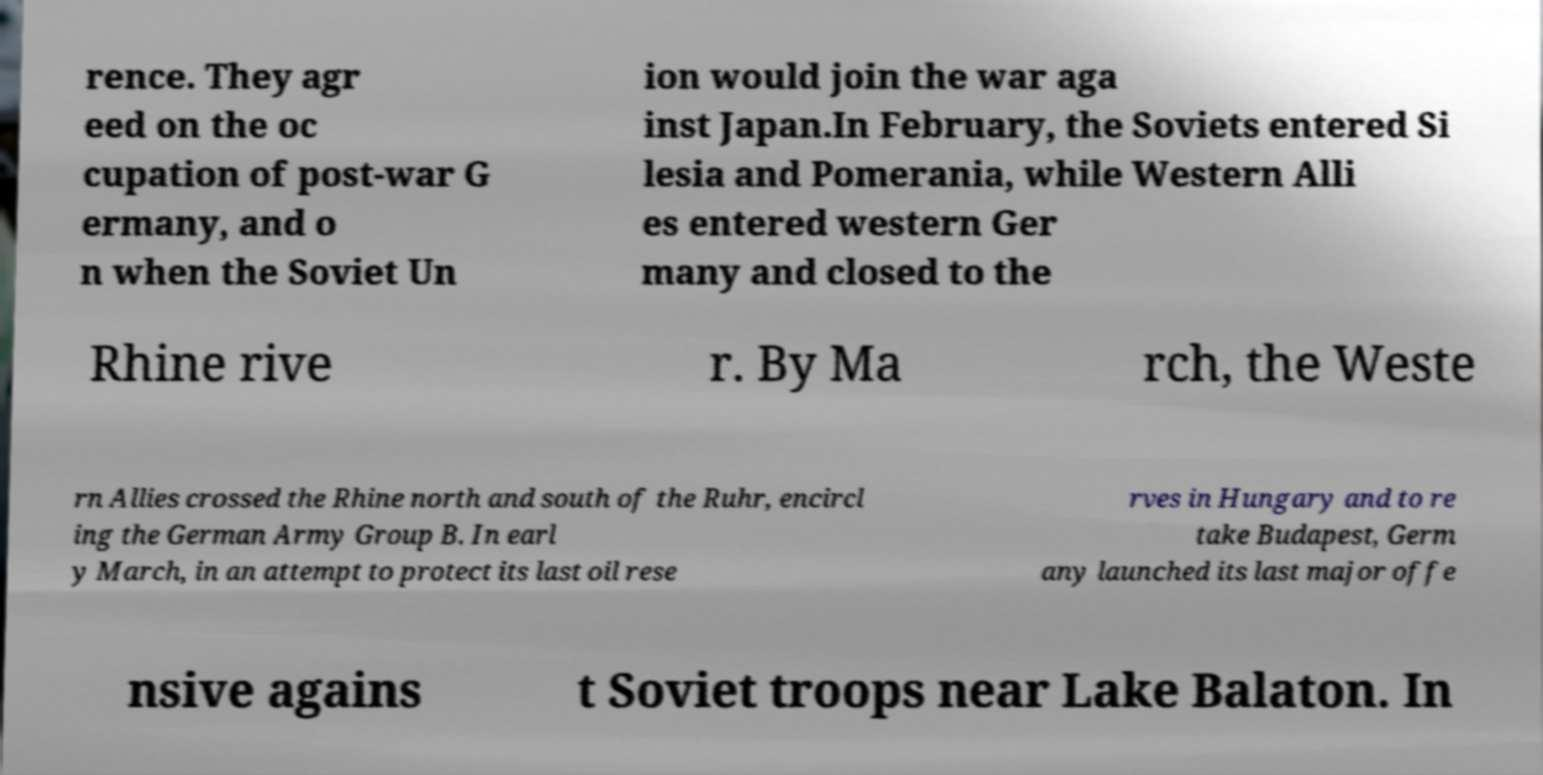What messages or text are displayed in this image? I need them in a readable, typed format. rence. They agr eed on the oc cupation of post-war G ermany, and o n when the Soviet Un ion would join the war aga inst Japan.In February, the Soviets entered Si lesia and Pomerania, while Western Alli es entered western Ger many and closed to the Rhine rive r. By Ma rch, the Weste rn Allies crossed the Rhine north and south of the Ruhr, encircl ing the German Army Group B. In earl y March, in an attempt to protect its last oil rese rves in Hungary and to re take Budapest, Germ any launched its last major offe nsive agains t Soviet troops near Lake Balaton. In 